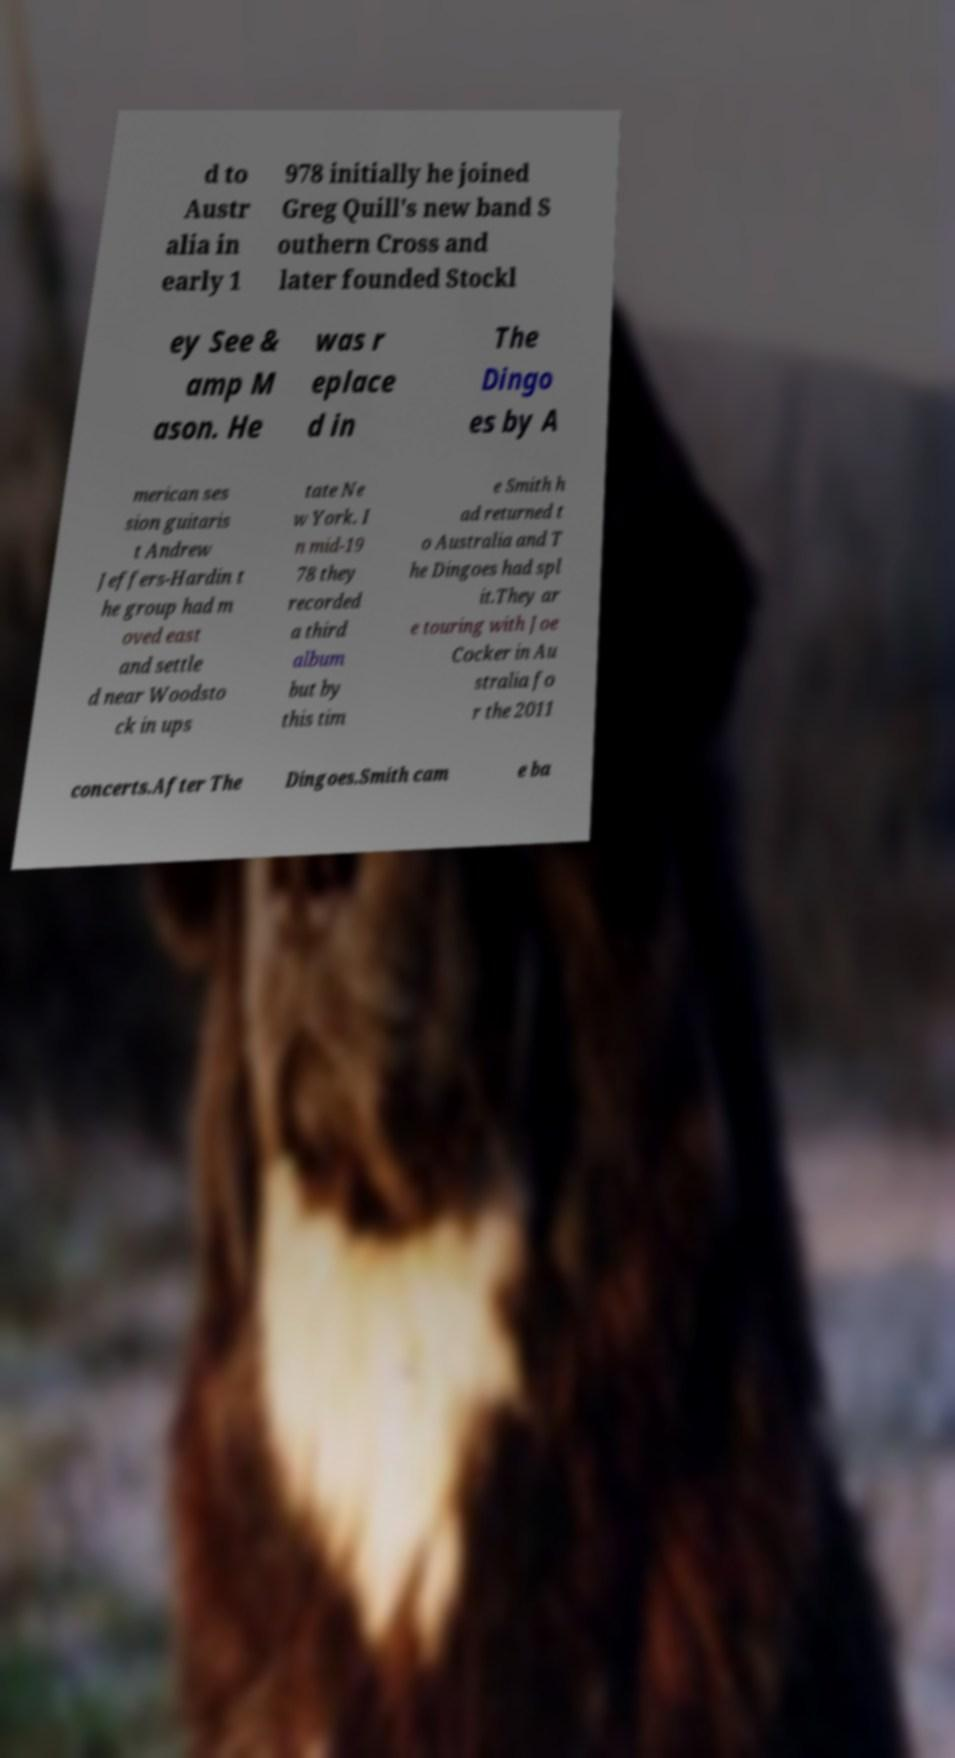Please read and relay the text visible in this image. What does it say? d to Austr alia in early 1 978 initially he joined Greg Quill's new band S outhern Cross and later founded Stockl ey See & amp M ason. He was r eplace d in The Dingo es by A merican ses sion guitaris t Andrew Jeffers-Hardin t he group had m oved east and settle d near Woodsto ck in ups tate Ne w York. I n mid-19 78 they recorded a third album but by this tim e Smith h ad returned t o Australia and T he Dingoes had spl it.They ar e touring with Joe Cocker in Au stralia fo r the 2011 concerts.After The Dingoes.Smith cam e ba 